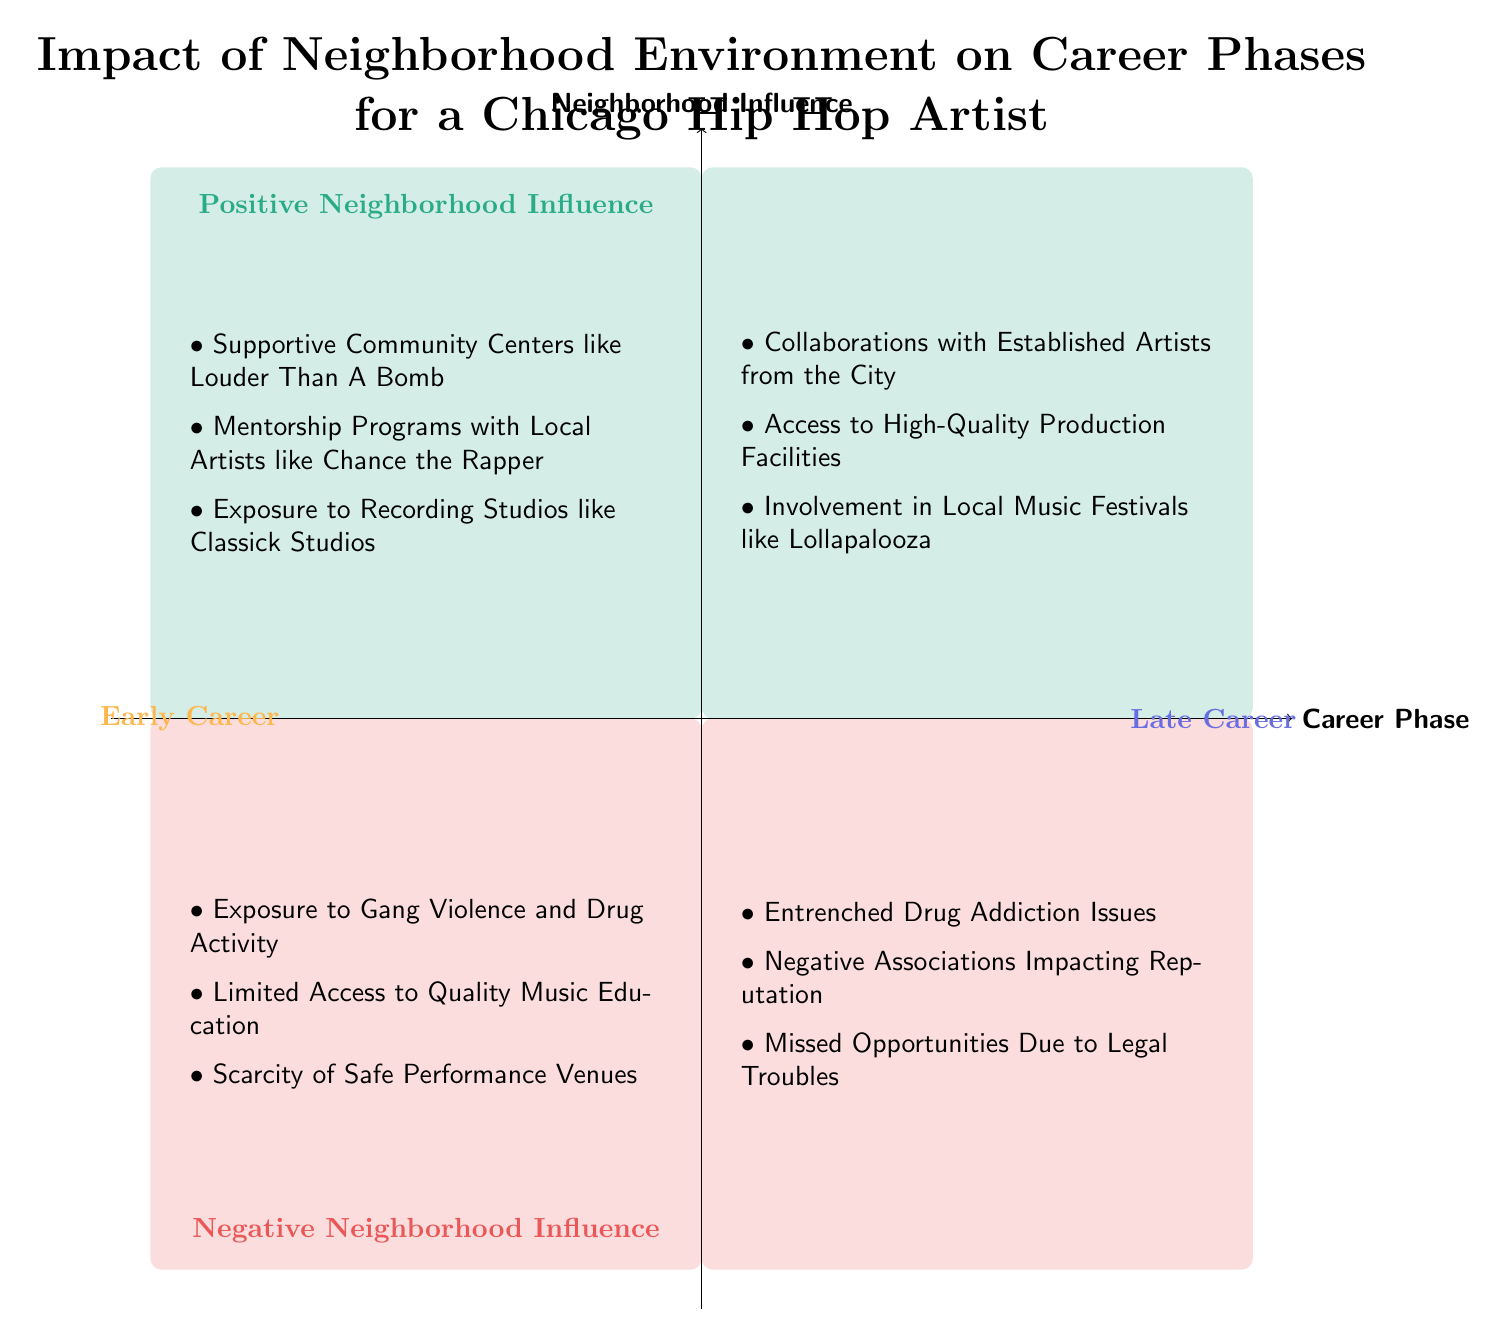What's in the "Positive Neighborhood Influence" quadrant for Early Career? The "Positive Neighborhood Influence" quadrant for Early Career contains three points: Supportive Community Centers like Louder Than A Bomb, Mentorship Programs with Local Artists like Chance the Rapper, and Exposure to Recording Studios like Classick Studios.
Answer: Supportive Community Centers like Louder Than A Bomb, Mentorship Programs with Local Artists like Chance the Rapper, Exposure to Recording Studios like Classick Studios How many influences are listed under "Negative Neighborhood Influence" for Late Career? The "Negative Neighborhood Influence" quadrant for Late Career lists three influences: Entrenched Drug Addiction Issues, Negative Associations Impacting Reputation, and Missed Opportunities Due to Legal Troubles. Thus, the number is three.
Answer: 3 What type of influences are found in the "Late Career" section of the diagram? The influences in the "Late Career" section of the diagram are categorized into two types: Positive Neighborhood Influence and Negative Neighborhood Influence.
Answer: Positive Neighborhood Influence and Negative Neighborhood Influence Which positive influences can contribute to a successful Late Career? In the "Late Career" section, the positive influences that can contribute include Collaborations with Established Artists from the City, Access to High-Quality Production Facilities, and Involvement in Local Music Festivals like Lollapalooza.
Answer: Collaborations with Established Artists, Access to High-Quality Production Facilities, Involvement in Local Music Festivals What negative influence is specifically associated with entrenched issues during the Late Career phase? The negative influence associated with entrenched issues during the Late Career phase is Entrenched Drug Addiction Issues. This points to a significant barrier that can hinder an artist's progress at this stage.
Answer: Entrenched Drug Addiction Issues What can be inferred about the impact of community support on an Early Career in Hip Hop? The diagram shows that community support, represented by Supportive Community Centers, Mentorship Programs, and Recording Studios, has a significant positive influence on an artist's Early Career. Thus, community support likely plays a crucial role in fostering talent and opportunities.
Answer: Community support is crucial for talent and opportunities 